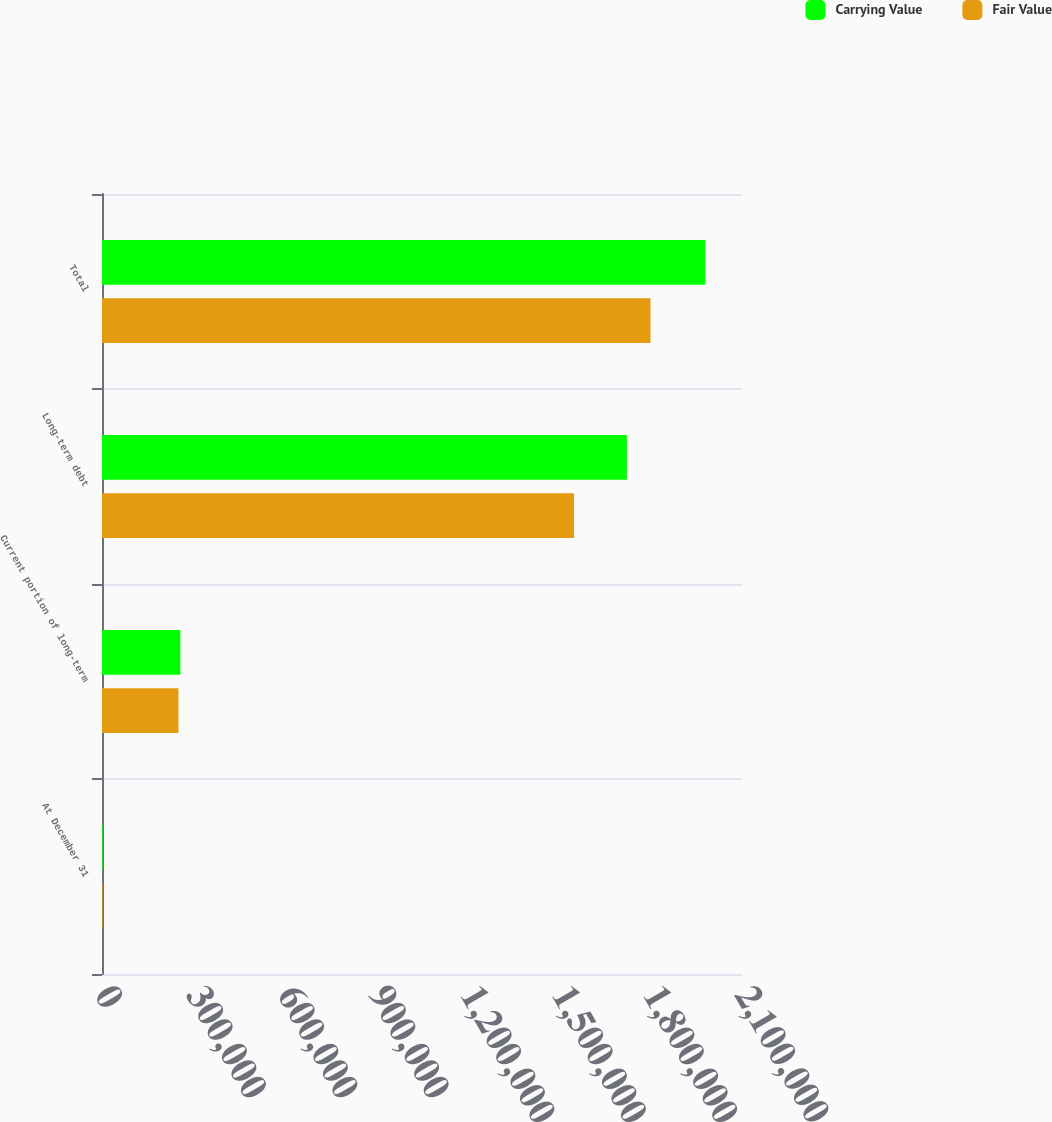Convert chart. <chart><loc_0><loc_0><loc_500><loc_500><stacked_bar_chart><ecel><fcel>At December 31<fcel>Current portion of long-term<fcel>Long-term debt<fcel>Total<nl><fcel>Carrying Value<fcel>2014<fcel>257280<fcel>1.72231e+06<fcel>1.97959e+06<nl><fcel>Fair Value<fcel>2014<fcel>250805<fcel>1.54896e+06<fcel>1.79977e+06<nl></chart> 